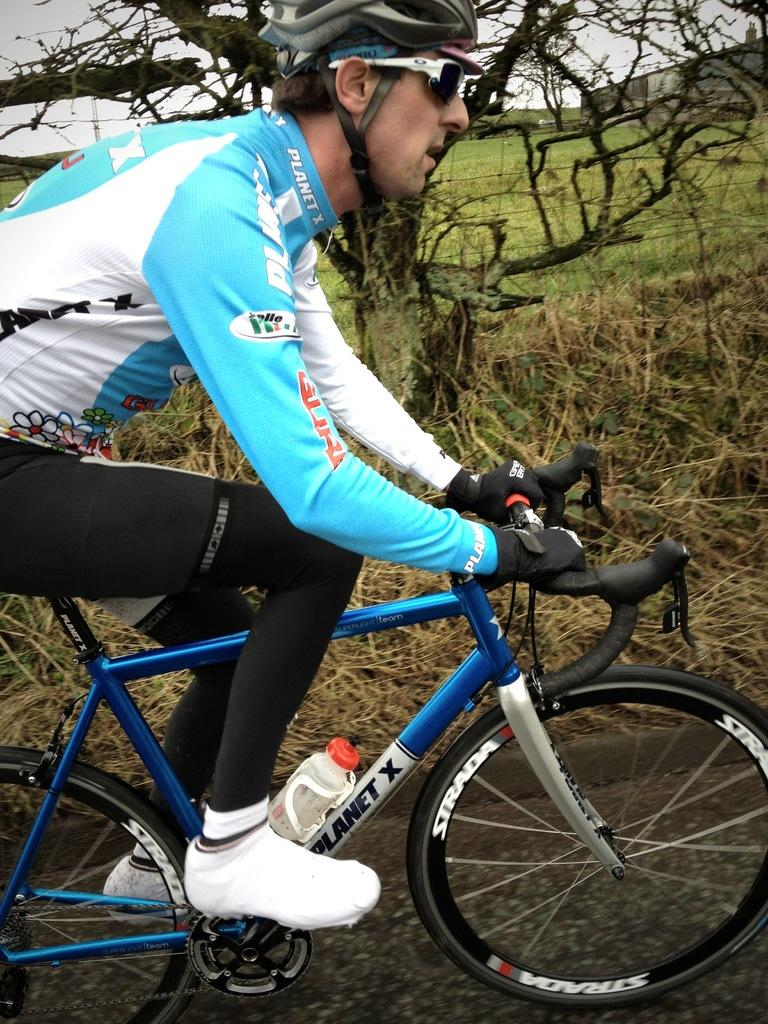What is the man in the image doing? The man is riding a bicycle in the image. Where is the bicycle located? The bicycle is on the road in the image. What type of vegetation can be seen in the image? There is grass visible in the image, and there is also a tree present. What is visible in the sky in the image? The sky is visible in the image, and it appears to be cloudy. What channel is the man watching on his bicycle in the image? There is no television or channel present in the image; the man is riding a bicycle on the road. What type of degree does the squirrel have in the image? There is no squirrel present in the image, so it is not possible to determine if it has a degree or not. 